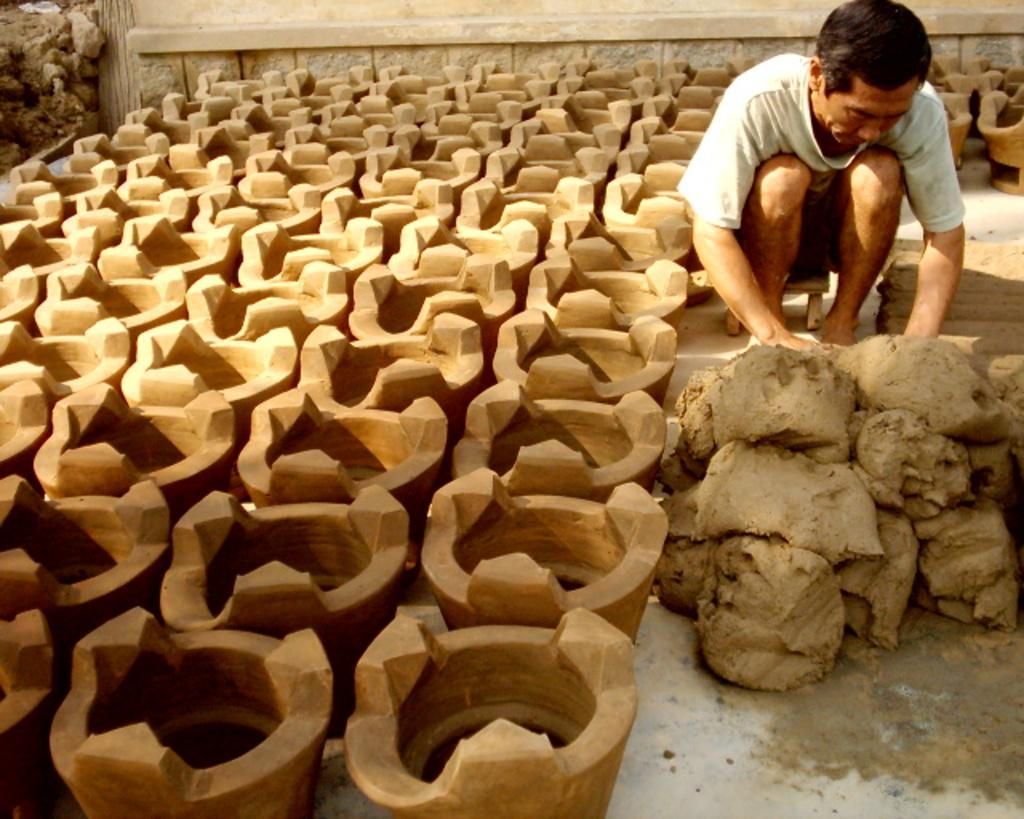What objects are present in the image? There are multiple pots in the image. What is the person in the image doing? The person is sitting on a stool. What material is the person working with? The person is in front of clay. What can be seen in the background of the image? There is a wall in the background of the image. What type of leather is being used by the person in the image? There is no leather present in the image; the person is working with clay. How many airplanes can be seen in the image? There are no airplanes present in the image. 